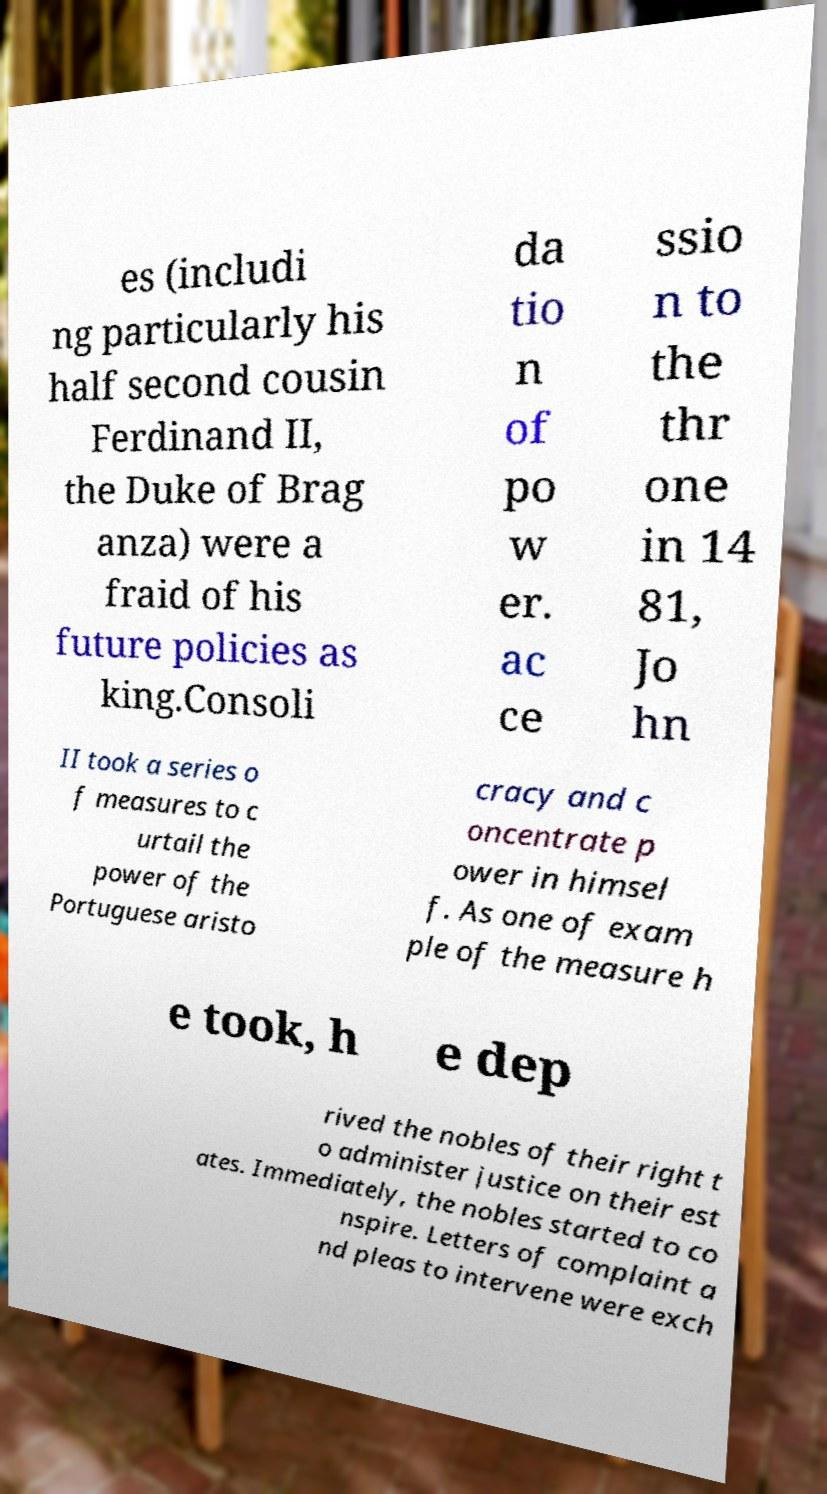Could you extract and type out the text from this image? es (includi ng particularly his half second cousin Ferdinand II, the Duke of Brag anza) were a fraid of his future policies as king.Consoli da tio n of po w er. ac ce ssio n to the thr one in 14 81, Jo hn II took a series o f measures to c urtail the power of the Portuguese aristo cracy and c oncentrate p ower in himsel f. As one of exam ple of the measure h e took, h e dep rived the nobles of their right t o administer justice on their est ates. Immediately, the nobles started to co nspire. Letters of complaint a nd pleas to intervene were exch 